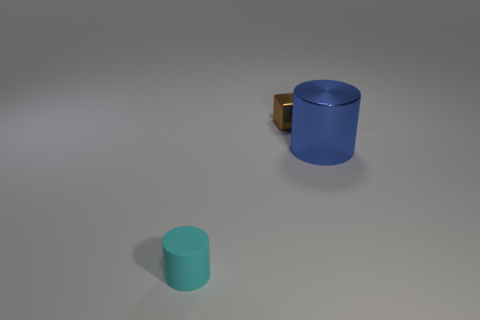Is there any other thing that is the same material as the cyan cylinder?
Give a very brief answer. No. Is there anything else that has the same size as the blue metallic thing?
Your answer should be very brief. No. There is a small thing in front of the blue metal thing; what is its material?
Offer a terse response. Rubber. Do the tiny object to the left of the tiny block and the small cube have the same material?
Give a very brief answer. No. The metallic object that is the same size as the cyan cylinder is what shape?
Provide a succinct answer. Cube. What number of other rubber objects are the same color as the large thing?
Provide a short and direct response. 0. Are there fewer blocks on the right side of the blue cylinder than brown blocks to the right of the brown metal block?
Give a very brief answer. No. There is a tiny brown metal object; are there any objects behind it?
Offer a very short reply. No. There is a cylinder in front of the cylinder behind the cyan cylinder; are there any things behind it?
Offer a terse response. Yes. There is a small object to the right of the cyan rubber cylinder; is it the same shape as the large thing?
Your answer should be compact. No. 